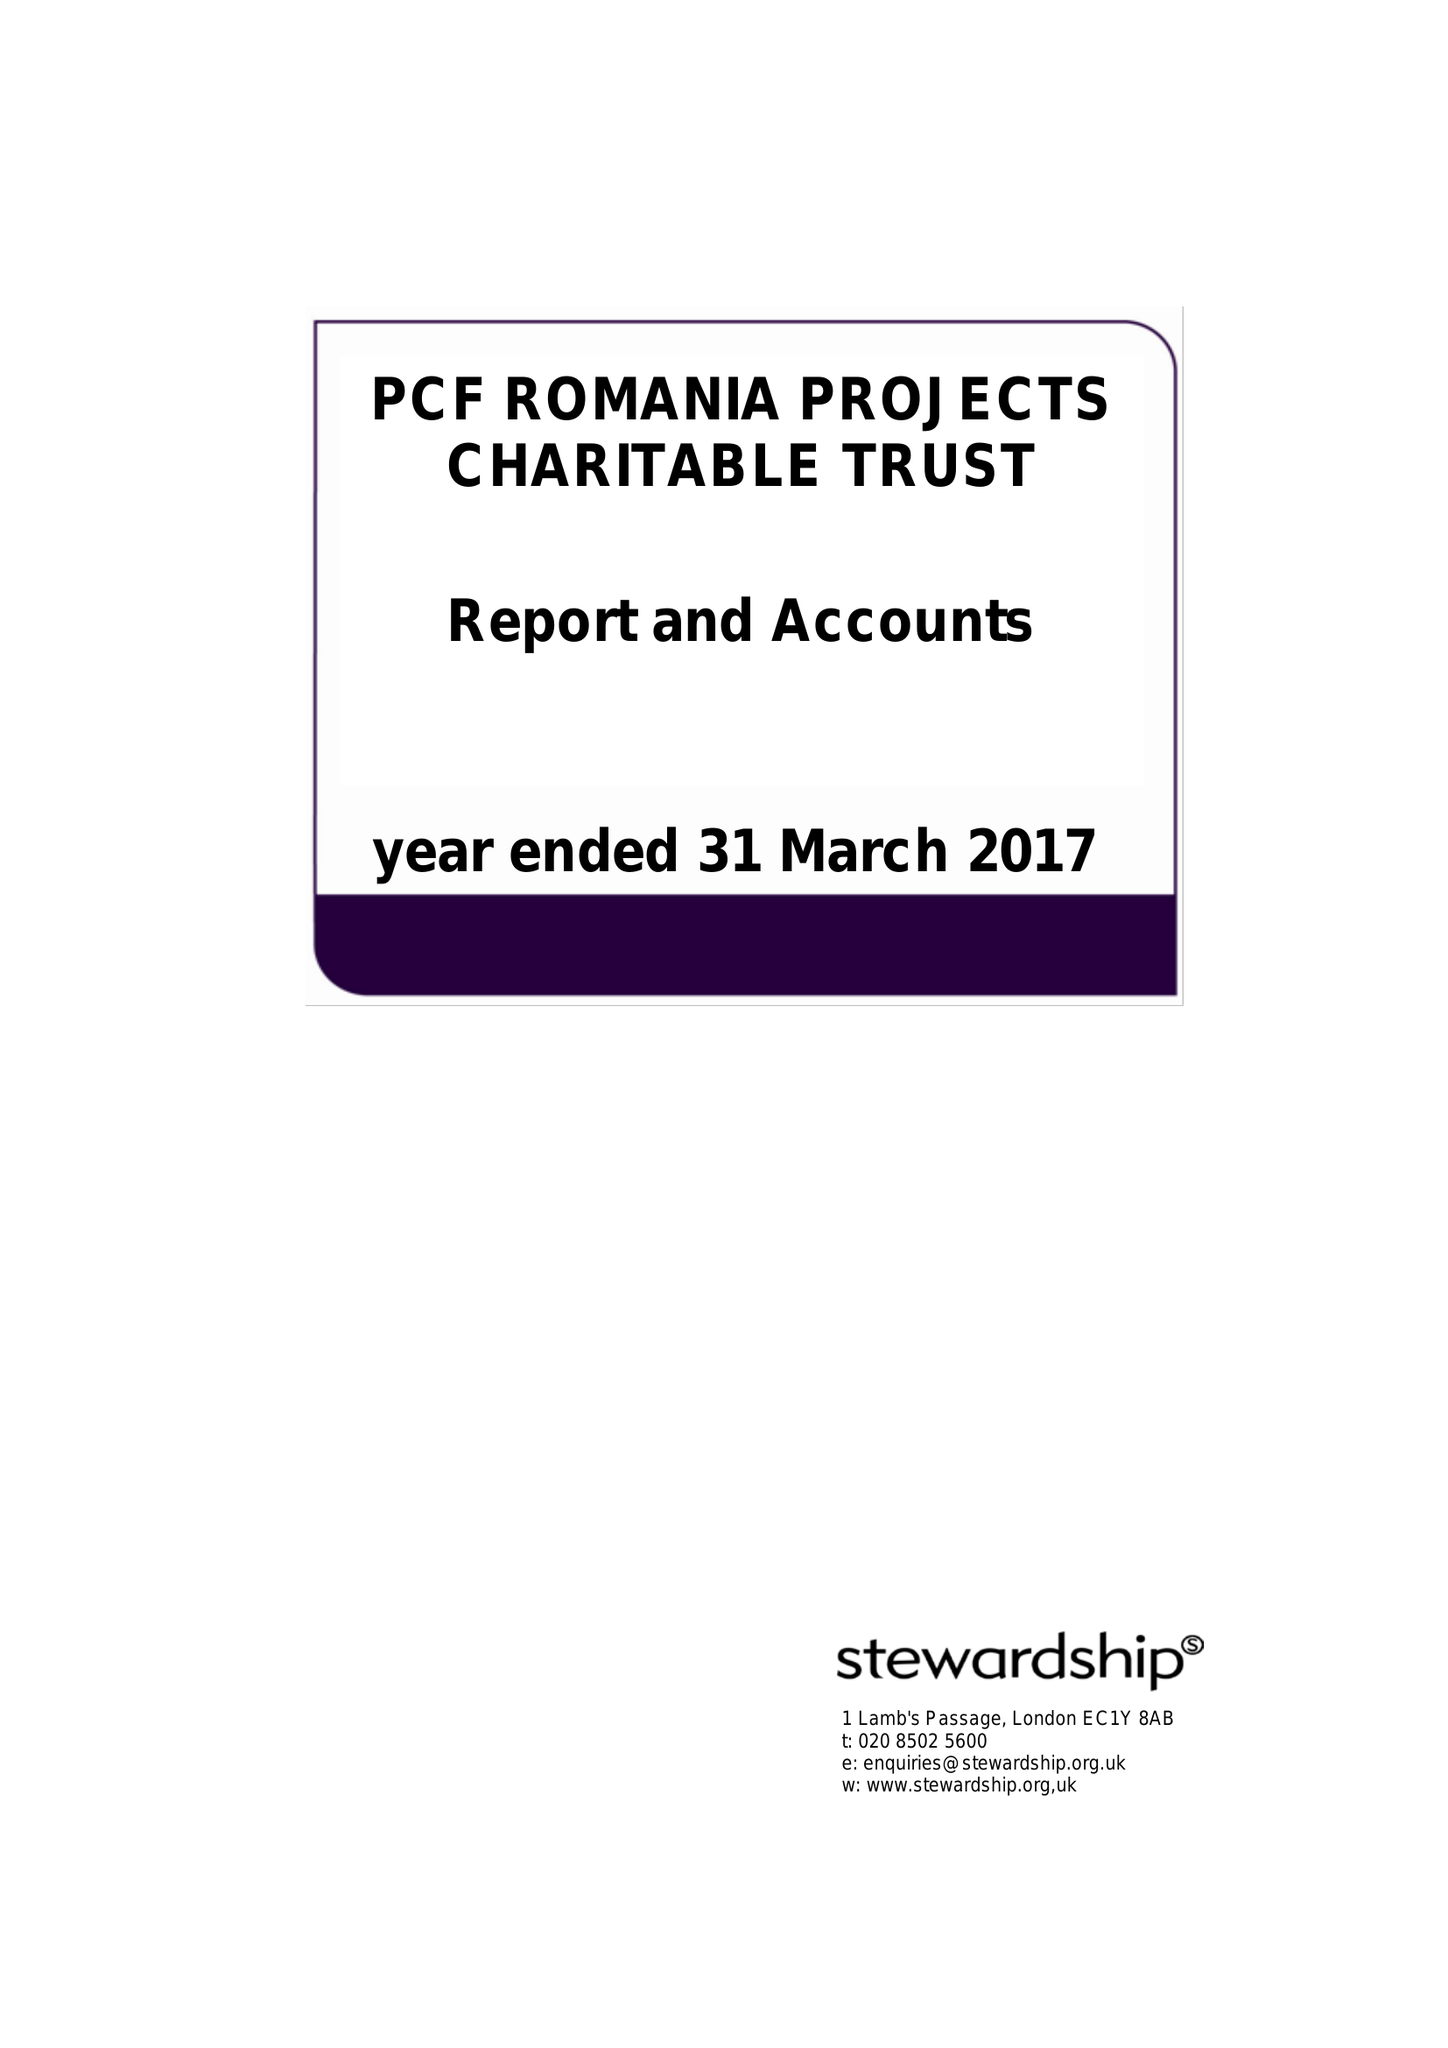What is the value for the spending_annually_in_british_pounds?
Answer the question using a single word or phrase. 90978.00 